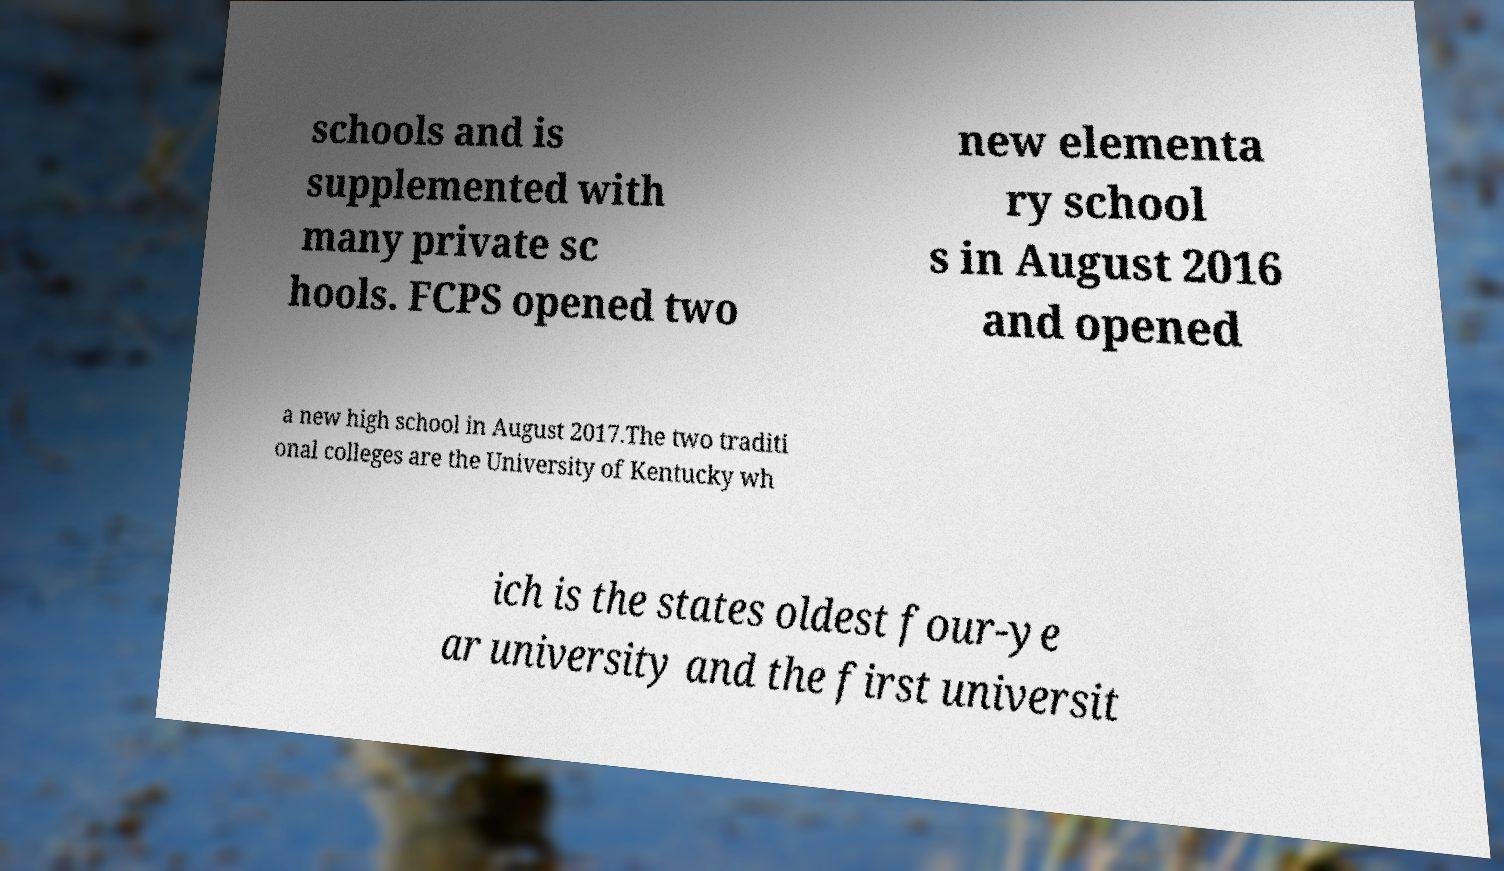Please read and relay the text visible in this image. What does it say? schools and is supplemented with many private sc hools. FCPS opened two new elementa ry school s in August 2016 and opened a new high school in August 2017.The two traditi onal colleges are the University of Kentucky wh ich is the states oldest four-ye ar university and the first universit 